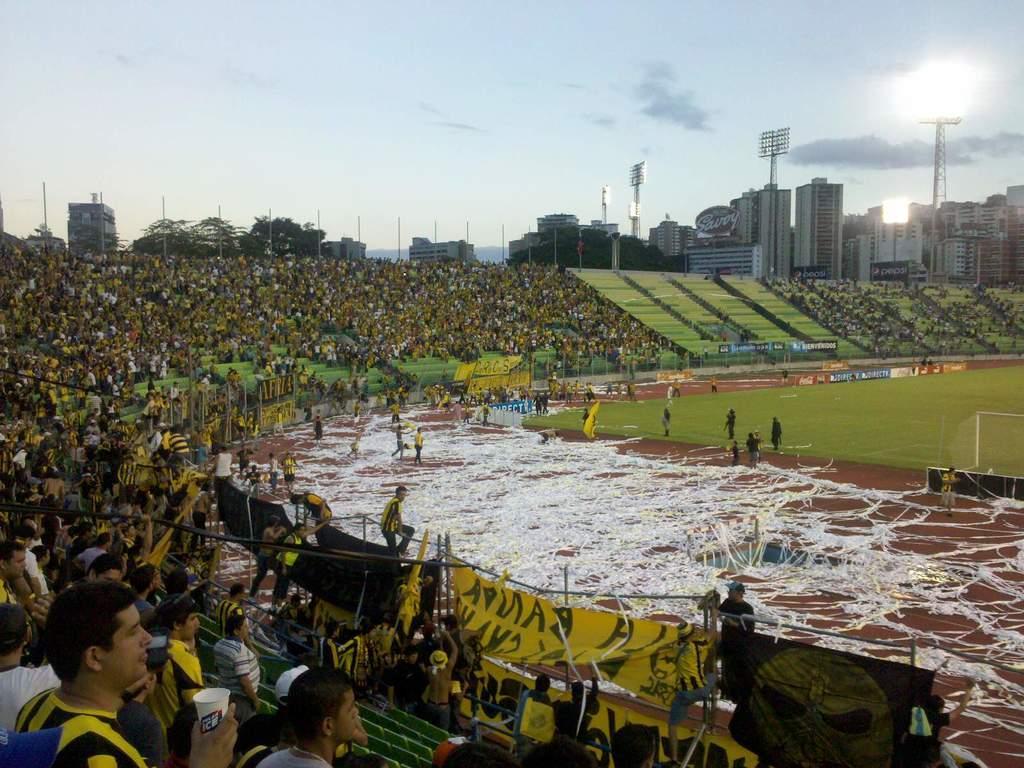Please provide a concise description of this image. There are groups of people standing and sitting. This looks like a football ground. I think these are the threads. I can see a banner. These are the floodlights and buildings. I can see the trees. 